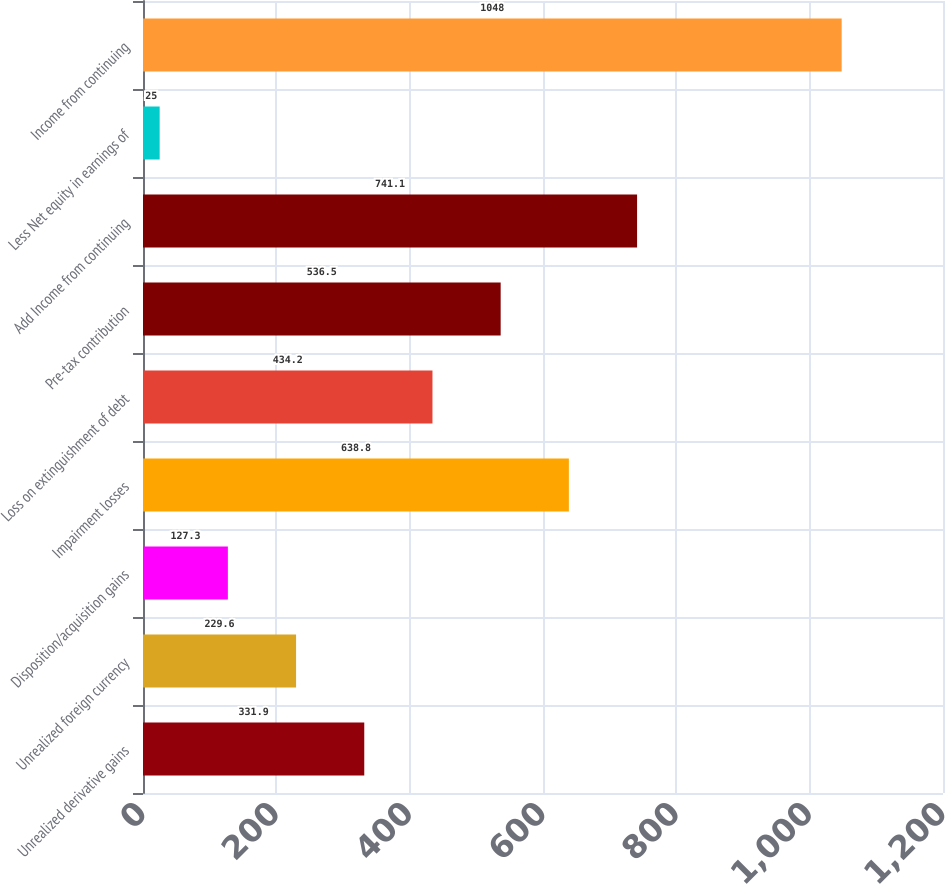Convert chart. <chart><loc_0><loc_0><loc_500><loc_500><bar_chart><fcel>Unrealized derivative gains<fcel>Unrealized foreign currency<fcel>Disposition/acquisition gains<fcel>Impairment losses<fcel>Loss on extinguishment of debt<fcel>Pre-tax contribution<fcel>Add Income from continuing<fcel>Less Net equity in earnings of<fcel>Income from continuing<nl><fcel>331.9<fcel>229.6<fcel>127.3<fcel>638.8<fcel>434.2<fcel>536.5<fcel>741.1<fcel>25<fcel>1048<nl></chart> 